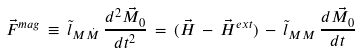Convert formula to latex. <formula><loc_0><loc_0><loc_500><loc_500>\vec { F } ^ { m a g } \, \equiv \, \tilde { l } _ { M \dot { M } } \, \frac { d ^ { 2 } \vec { M } _ { 0 } } { d t ^ { 2 } } \, = \, ( \vec { H } \, - \, \vec { H } ^ { e x t } ) \, - \, \tilde { l } _ { M M } \, \frac { d \vec { M _ { 0 } } } { d t }</formula> 